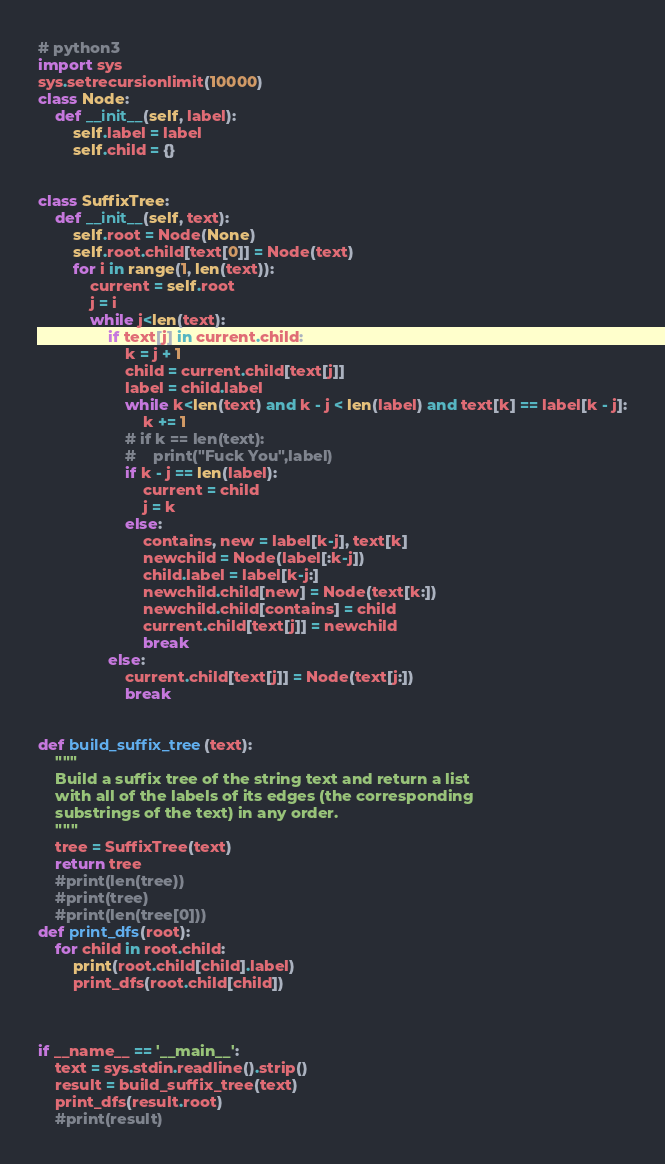<code> <loc_0><loc_0><loc_500><loc_500><_Python_># python3
import sys
sys.setrecursionlimit(10000)
class Node:
    def __init__(self, label):
        self.label = label
        self.child = {}


class SuffixTree:
    def __init__(self, text):
        self.root = Node(None)
        self.root.child[text[0]] = Node(text)
        for i in range(1, len(text)):
            current = self.root
            j = i
            while j<len(text):
                if text[j] in current.child:
                    k = j + 1
                    child = current.child[text[j]]
                    label = child.label
                    while k<len(text) and k - j < len(label) and text[k] == label[k - j]:
                        k += 1
                    # if k == len(text):
                    #    print("Fuck You",label)
                    if k - j == len(label):
                        current = child
                        j = k
                    else:
                        contains, new = label[k-j], text[k]
                        newchild = Node(label[:k-j])
                        child.label = label[k-j:]
                        newchild.child[new] = Node(text[k:])
                        newchild.child[contains] = child
                        current.child[text[j]] = newchild
                        break
                else:
                    current.child[text[j]] = Node(text[j:])
                    break


def build_suffix_tree(text):
    """
    Build a suffix tree of the string text and return a list
    with all of the labels of its edges (the corresponding 
    substrings of the text) in any order.
    """
    tree = SuffixTree(text)
    return tree 
    #print(len(tree))
    #print(tree)
    #print(len(tree[0]))
def print_dfs(root):
    for child in root.child:
        print(root.child[child].label)
        print_dfs(root.child[child])

    

if __name__ == '__main__':
    text = sys.stdin.readline().strip()
    result = build_suffix_tree(text)
    print_dfs(result.root)
    #print(result)
</code> 